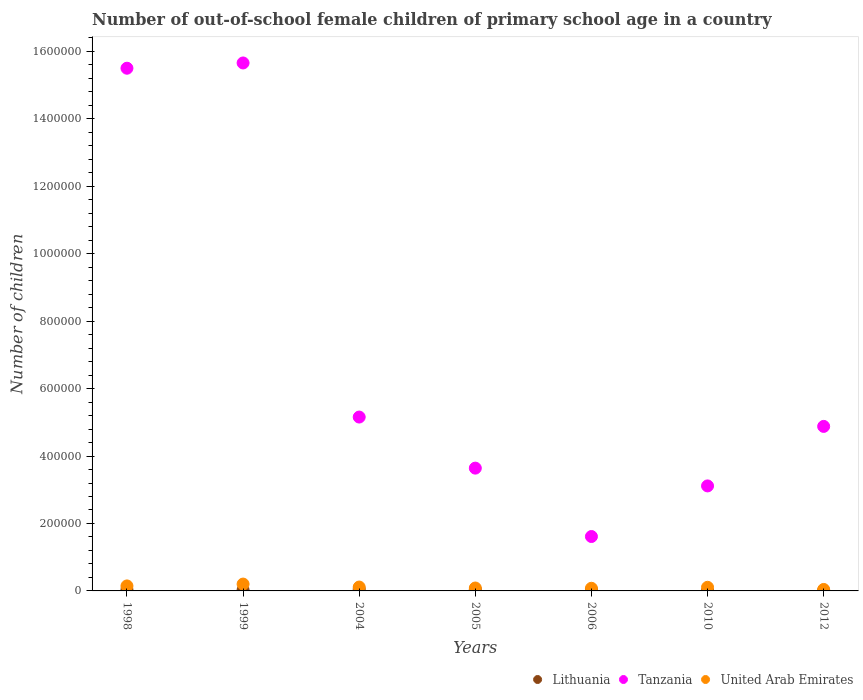How many different coloured dotlines are there?
Offer a terse response. 3. Is the number of dotlines equal to the number of legend labels?
Keep it short and to the point. Yes. What is the number of out-of-school female children in Tanzania in 2006?
Your answer should be very brief. 1.61e+05. Across all years, what is the maximum number of out-of-school female children in Lithuania?
Ensure brevity in your answer.  5354. Across all years, what is the minimum number of out-of-school female children in Lithuania?
Provide a succinct answer. 857. In which year was the number of out-of-school female children in Tanzania maximum?
Provide a succinct answer. 1999. What is the total number of out-of-school female children in Lithuania in the graph?
Your answer should be compact. 2.16e+04. What is the difference between the number of out-of-school female children in Tanzania in 2005 and that in 2006?
Your answer should be compact. 2.03e+05. What is the difference between the number of out-of-school female children in Tanzania in 1998 and the number of out-of-school female children in Lithuania in 2005?
Keep it short and to the point. 1.55e+06. What is the average number of out-of-school female children in United Arab Emirates per year?
Give a very brief answer. 1.12e+04. In the year 1999, what is the difference between the number of out-of-school female children in Tanzania and number of out-of-school female children in United Arab Emirates?
Your response must be concise. 1.55e+06. In how many years, is the number of out-of-school female children in Lithuania greater than 1200000?
Offer a terse response. 0. What is the ratio of the number of out-of-school female children in Tanzania in 1999 to that in 2006?
Your response must be concise. 9.7. Is the number of out-of-school female children in Lithuania in 2004 less than that in 2012?
Provide a succinct answer. No. Is the difference between the number of out-of-school female children in Tanzania in 1999 and 2010 greater than the difference between the number of out-of-school female children in United Arab Emirates in 1999 and 2010?
Your response must be concise. Yes. What is the difference between the highest and the second highest number of out-of-school female children in Tanzania?
Provide a short and direct response. 1.56e+04. What is the difference between the highest and the lowest number of out-of-school female children in United Arab Emirates?
Offer a terse response. 1.59e+04. In how many years, is the number of out-of-school female children in United Arab Emirates greater than the average number of out-of-school female children in United Arab Emirates taken over all years?
Your answer should be compact. 3. Is it the case that in every year, the sum of the number of out-of-school female children in United Arab Emirates and number of out-of-school female children in Lithuania  is greater than the number of out-of-school female children in Tanzania?
Keep it short and to the point. No. Does the number of out-of-school female children in Tanzania monotonically increase over the years?
Offer a very short reply. No. Is the number of out-of-school female children in Tanzania strictly greater than the number of out-of-school female children in United Arab Emirates over the years?
Make the answer very short. Yes. Is the number of out-of-school female children in United Arab Emirates strictly less than the number of out-of-school female children in Lithuania over the years?
Keep it short and to the point. No. How many years are there in the graph?
Provide a succinct answer. 7. What is the difference between two consecutive major ticks on the Y-axis?
Give a very brief answer. 2.00e+05. Does the graph contain grids?
Keep it short and to the point. No. Where does the legend appear in the graph?
Provide a succinct answer. Bottom right. How many legend labels are there?
Your response must be concise. 3. How are the legend labels stacked?
Provide a short and direct response. Horizontal. What is the title of the graph?
Your answer should be compact. Number of out-of-school female children of primary school age in a country. What is the label or title of the Y-axis?
Provide a short and direct response. Number of children. What is the Number of children of Lithuania in 1998?
Your answer should be compact. 3783. What is the Number of children in Tanzania in 1998?
Your answer should be compact. 1.55e+06. What is the Number of children in United Arab Emirates in 1998?
Your answer should be compact. 1.48e+04. What is the Number of children of Lithuania in 1999?
Provide a succinct answer. 2998. What is the Number of children of Tanzania in 1999?
Provide a short and direct response. 1.57e+06. What is the Number of children of United Arab Emirates in 1999?
Keep it short and to the point. 2.03e+04. What is the Number of children of Lithuania in 2004?
Keep it short and to the point. 5354. What is the Number of children in Tanzania in 2004?
Ensure brevity in your answer.  5.16e+05. What is the Number of children of United Arab Emirates in 2004?
Give a very brief answer. 1.15e+04. What is the Number of children of Lithuania in 2005?
Make the answer very short. 4559. What is the Number of children of Tanzania in 2005?
Your response must be concise. 3.64e+05. What is the Number of children in United Arab Emirates in 2005?
Offer a very short reply. 8644. What is the Number of children in Lithuania in 2006?
Make the answer very short. 2854. What is the Number of children of Tanzania in 2006?
Your answer should be compact. 1.61e+05. What is the Number of children in United Arab Emirates in 2006?
Ensure brevity in your answer.  7870. What is the Number of children in Lithuania in 2010?
Provide a succinct answer. 857. What is the Number of children of Tanzania in 2010?
Keep it short and to the point. 3.11e+05. What is the Number of children in United Arab Emirates in 2010?
Give a very brief answer. 1.08e+04. What is the Number of children in Lithuania in 2012?
Provide a succinct answer. 1167. What is the Number of children of Tanzania in 2012?
Ensure brevity in your answer.  4.88e+05. What is the Number of children of United Arab Emirates in 2012?
Your response must be concise. 4362. Across all years, what is the maximum Number of children in Lithuania?
Make the answer very short. 5354. Across all years, what is the maximum Number of children in Tanzania?
Your answer should be compact. 1.57e+06. Across all years, what is the maximum Number of children of United Arab Emirates?
Offer a very short reply. 2.03e+04. Across all years, what is the minimum Number of children in Lithuania?
Provide a short and direct response. 857. Across all years, what is the minimum Number of children in Tanzania?
Provide a succinct answer. 1.61e+05. Across all years, what is the minimum Number of children in United Arab Emirates?
Your answer should be very brief. 4362. What is the total Number of children of Lithuania in the graph?
Provide a short and direct response. 2.16e+04. What is the total Number of children of Tanzania in the graph?
Provide a succinct answer. 4.96e+06. What is the total Number of children in United Arab Emirates in the graph?
Give a very brief answer. 7.83e+04. What is the difference between the Number of children of Lithuania in 1998 and that in 1999?
Ensure brevity in your answer.  785. What is the difference between the Number of children of Tanzania in 1998 and that in 1999?
Your answer should be very brief. -1.56e+04. What is the difference between the Number of children of United Arab Emirates in 1998 and that in 1999?
Offer a terse response. -5477. What is the difference between the Number of children in Lithuania in 1998 and that in 2004?
Make the answer very short. -1571. What is the difference between the Number of children in Tanzania in 1998 and that in 2004?
Your answer should be very brief. 1.03e+06. What is the difference between the Number of children in United Arab Emirates in 1998 and that in 2004?
Give a very brief answer. 3322. What is the difference between the Number of children in Lithuania in 1998 and that in 2005?
Make the answer very short. -776. What is the difference between the Number of children in Tanzania in 1998 and that in 2005?
Keep it short and to the point. 1.19e+06. What is the difference between the Number of children in United Arab Emirates in 1998 and that in 2005?
Provide a succinct answer. 6178. What is the difference between the Number of children in Lithuania in 1998 and that in 2006?
Provide a short and direct response. 929. What is the difference between the Number of children of Tanzania in 1998 and that in 2006?
Ensure brevity in your answer.  1.39e+06. What is the difference between the Number of children of United Arab Emirates in 1998 and that in 2006?
Provide a succinct answer. 6952. What is the difference between the Number of children in Lithuania in 1998 and that in 2010?
Make the answer very short. 2926. What is the difference between the Number of children in Tanzania in 1998 and that in 2010?
Give a very brief answer. 1.24e+06. What is the difference between the Number of children in United Arab Emirates in 1998 and that in 2010?
Your answer should be very brief. 4048. What is the difference between the Number of children in Lithuania in 1998 and that in 2012?
Ensure brevity in your answer.  2616. What is the difference between the Number of children in Tanzania in 1998 and that in 2012?
Your response must be concise. 1.06e+06. What is the difference between the Number of children in United Arab Emirates in 1998 and that in 2012?
Your answer should be compact. 1.05e+04. What is the difference between the Number of children in Lithuania in 1999 and that in 2004?
Provide a succinct answer. -2356. What is the difference between the Number of children in Tanzania in 1999 and that in 2004?
Make the answer very short. 1.05e+06. What is the difference between the Number of children in United Arab Emirates in 1999 and that in 2004?
Offer a terse response. 8799. What is the difference between the Number of children of Lithuania in 1999 and that in 2005?
Offer a very short reply. -1561. What is the difference between the Number of children of Tanzania in 1999 and that in 2005?
Provide a succinct answer. 1.20e+06. What is the difference between the Number of children in United Arab Emirates in 1999 and that in 2005?
Make the answer very short. 1.17e+04. What is the difference between the Number of children in Lithuania in 1999 and that in 2006?
Your answer should be compact. 144. What is the difference between the Number of children of Tanzania in 1999 and that in 2006?
Offer a terse response. 1.40e+06. What is the difference between the Number of children in United Arab Emirates in 1999 and that in 2006?
Make the answer very short. 1.24e+04. What is the difference between the Number of children in Lithuania in 1999 and that in 2010?
Offer a very short reply. 2141. What is the difference between the Number of children in Tanzania in 1999 and that in 2010?
Provide a succinct answer. 1.25e+06. What is the difference between the Number of children of United Arab Emirates in 1999 and that in 2010?
Your answer should be very brief. 9525. What is the difference between the Number of children in Lithuania in 1999 and that in 2012?
Ensure brevity in your answer.  1831. What is the difference between the Number of children in Tanzania in 1999 and that in 2012?
Your answer should be compact. 1.08e+06. What is the difference between the Number of children of United Arab Emirates in 1999 and that in 2012?
Give a very brief answer. 1.59e+04. What is the difference between the Number of children in Lithuania in 2004 and that in 2005?
Your answer should be very brief. 795. What is the difference between the Number of children in Tanzania in 2004 and that in 2005?
Your response must be concise. 1.51e+05. What is the difference between the Number of children in United Arab Emirates in 2004 and that in 2005?
Offer a very short reply. 2856. What is the difference between the Number of children in Lithuania in 2004 and that in 2006?
Provide a short and direct response. 2500. What is the difference between the Number of children of Tanzania in 2004 and that in 2006?
Give a very brief answer. 3.54e+05. What is the difference between the Number of children in United Arab Emirates in 2004 and that in 2006?
Give a very brief answer. 3630. What is the difference between the Number of children of Lithuania in 2004 and that in 2010?
Ensure brevity in your answer.  4497. What is the difference between the Number of children in Tanzania in 2004 and that in 2010?
Offer a very short reply. 2.04e+05. What is the difference between the Number of children of United Arab Emirates in 2004 and that in 2010?
Your response must be concise. 726. What is the difference between the Number of children of Lithuania in 2004 and that in 2012?
Offer a terse response. 4187. What is the difference between the Number of children of Tanzania in 2004 and that in 2012?
Make the answer very short. 2.77e+04. What is the difference between the Number of children in United Arab Emirates in 2004 and that in 2012?
Your answer should be compact. 7138. What is the difference between the Number of children of Lithuania in 2005 and that in 2006?
Your answer should be compact. 1705. What is the difference between the Number of children in Tanzania in 2005 and that in 2006?
Your answer should be very brief. 2.03e+05. What is the difference between the Number of children in United Arab Emirates in 2005 and that in 2006?
Your response must be concise. 774. What is the difference between the Number of children of Lithuania in 2005 and that in 2010?
Offer a very short reply. 3702. What is the difference between the Number of children of Tanzania in 2005 and that in 2010?
Provide a succinct answer. 5.27e+04. What is the difference between the Number of children in United Arab Emirates in 2005 and that in 2010?
Your answer should be very brief. -2130. What is the difference between the Number of children of Lithuania in 2005 and that in 2012?
Your response must be concise. 3392. What is the difference between the Number of children of Tanzania in 2005 and that in 2012?
Your answer should be compact. -1.24e+05. What is the difference between the Number of children in United Arab Emirates in 2005 and that in 2012?
Your answer should be compact. 4282. What is the difference between the Number of children of Lithuania in 2006 and that in 2010?
Your answer should be compact. 1997. What is the difference between the Number of children of Tanzania in 2006 and that in 2010?
Your response must be concise. -1.50e+05. What is the difference between the Number of children of United Arab Emirates in 2006 and that in 2010?
Provide a succinct answer. -2904. What is the difference between the Number of children of Lithuania in 2006 and that in 2012?
Offer a very short reply. 1687. What is the difference between the Number of children of Tanzania in 2006 and that in 2012?
Keep it short and to the point. -3.27e+05. What is the difference between the Number of children of United Arab Emirates in 2006 and that in 2012?
Your answer should be compact. 3508. What is the difference between the Number of children in Lithuania in 2010 and that in 2012?
Give a very brief answer. -310. What is the difference between the Number of children in Tanzania in 2010 and that in 2012?
Keep it short and to the point. -1.76e+05. What is the difference between the Number of children of United Arab Emirates in 2010 and that in 2012?
Keep it short and to the point. 6412. What is the difference between the Number of children of Lithuania in 1998 and the Number of children of Tanzania in 1999?
Offer a very short reply. -1.56e+06. What is the difference between the Number of children in Lithuania in 1998 and the Number of children in United Arab Emirates in 1999?
Provide a succinct answer. -1.65e+04. What is the difference between the Number of children in Tanzania in 1998 and the Number of children in United Arab Emirates in 1999?
Keep it short and to the point. 1.53e+06. What is the difference between the Number of children in Lithuania in 1998 and the Number of children in Tanzania in 2004?
Offer a terse response. -5.12e+05. What is the difference between the Number of children in Lithuania in 1998 and the Number of children in United Arab Emirates in 2004?
Offer a very short reply. -7717. What is the difference between the Number of children in Tanzania in 1998 and the Number of children in United Arab Emirates in 2004?
Offer a very short reply. 1.54e+06. What is the difference between the Number of children of Lithuania in 1998 and the Number of children of Tanzania in 2005?
Provide a short and direct response. -3.60e+05. What is the difference between the Number of children in Lithuania in 1998 and the Number of children in United Arab Emirates in 2005?
Your response must be concise. -4861. What is the difference between the Number of children in Tanzania in 1998 and the Number of children in United Arab Emirates in 2005?
Offer a terse response. 1.54e+06. What is the difference between the Number of children in Lithuania in 1998 and the Number of children in Tanzania in 2006?
Give a very brief answer. -1.58e+05. What is the difference between the Number of children of Lithuania in 1998 and the Number of children of United Arab Emirates in 2006?
Offer a terse response. -4087. What is the difference between the Number of children in Tanzania in 1998 and the Number of children in United Arab Emirates in 2006?
Your answer should be very brief. 1.54e+06. What is the difference between the Number of children in Lithuania in 1998 and the Number of children in Tanzania in 2010?
Offer a terse response. -3.08e+05. What is the difference between the Number of children of Lithuania in 1998 and the Number of children of United Arab Emirates in 2010?
Provide a succinct answer. -6991. What is the difference between the Number of children in Tanzania in 1998 and the Number of children in United Arab Emirates in 2010?
Ensure brevity in your answer.  1.54e+06. What is the difference between the Number of children in Lithuania in 1998 and the Number of children in Tanzania in 2012?
Keep it short and to the point. -4.84e+05. What is the difference between the Number of children of Lithuania in 1998 and the Number of children of United Arab Emirates in 2012?
Your answer should be very brief. -579. What is the difference between the Number of children of Tanzania in 1998 and the Number of children of United Arab Emirates in 2012?
Make the answer very short. 1.55e+06. What is the difference between the Number of children in Lithuania in 1999 and the Number of children in Tanzania in 2004?
Your answer should be very brief. -5.13e+05. What is the difference between the Number of children in Lithuania in 1999 and the Number of children in United Arab Emirates in 2004?
Ensure brevity in your answer.  -8502. What is the difference between the Number of children in Tanzania in 1999 and the Number of children in United Arab Emirates in 2004?
Provide a short and direct response. 1.55e+06. What is the difference between the Number of children in Lithuania in 1999 and the Number of children in Tanzania in 2005?
Your answer should be very brief. -3.61e+05. What is the difference between the Number of children in Lithuania in 1999 and the Number of children in United Arab Emirates in 2005?
Provide a succinct answer. -5646. What is the difference between the Number of children of Tanzania in 1999 and the Number of children of United Arab Emirates in 2005?
Offer a terse response. 1.56e+06. What is the difference between the Number of children in Lithuania in 1999 and the Number of children in Tanzania in 2006?
Provide a succinct answer. -1.58e+05. What is the difference between the Number of children in Lithuania in 1999 and the Number of children in United Arab Emirates in 2006?
Give a very brief answer. -4872. What is the difference between the Number of children in Tanzania in 1999 and the Number of children in United Arab Emirates in 2006?
Give a very brief answer. 1.56e+06. What is the difference between the Number of children of Lithuania in 1999 and the Number of children of Tanzania in 2010?
Your response must be concise. -3.08e+05. What is the difference between the Number of children of Lithuania in 1999 and the Number of children of United Arab Emirates in 2010?
Ensure brevity in your answer.  -7776. What is the difference between the Number of children of Tanzania in 1999 and the Number of children of United Arab Emirates in 2010?
Offer a very short reply. 1.55e+06. What is the difference between the Number of children of Lithuania in 1999 and the Number of children of Tanzania in 2012?
Offer a terse response. -4.85e+05. What is the difference between the Number of children in Lithuania in 1999 and the Number of children in United Arab Emirates in 2012?
Ensure brevity in your answer.  -1364. What is the difference between the Number of children of Tanzania in 1999 and the Number of children of United Arab Emirates in 2012?
Make the answer very short. 1.56e+06. What is the difference between the Number of children of Lithuania in 2004 and the Number of children of Tanzania in 2005?
Provide a succinct answer. -3.59e+05. What is the difference between the Number of children of Lithuania in 2004 and the Number of children of United Arab Emirates in 2005?
Make the answer very short. -3290. What is the difference between the Number of children of Tanzania in 2004 and the Number of children of United Arab Emirates in 2005?
Give a very brief answer. 5.07e+05. What is the difference between the Number of children of Lithuania in 2004 and the Number of children of Tanzania in 2006?
Ensure brevity in your answer.  -1.56e+05. What is the difference between the Number of children of Lithuania in 2004 and the Number of children of United Arab Emirates in 2006?
Make the answer very short. -2516. What is the difference between the Number of children of Tanzania in 2004 and the Number of children of United Arab Emirates in 2006?
Provide a short and direct response. 5.08e+05. What is the difference between the Number of children of Lithuania in 2004 and the Number of children of Tanzania in 2010?
Keep it short and to the point. -3.06e+05. What is the difference between the Number of children of Lithuania in 2004 and the Number of children of United Arab Emirates in 2010?
Provide a succinct answer. -5420. What is the difference between the Number of children in Tanzania in 2004 and the Number of children in United Arab Emirates in 2010?
Offer a terse response. 5.05e+05. What is the difference between the Number of children in Lithuania in 2004 and the Number of children in Tanzania in 2012?
Provide a succinct answer. -4.83e+05. What is the difference between the Number of children in Lithuania in 2004 and the Number of children in United Arab Emirates in 2012?
Your answer should be compact. 992. What is the difference between the Number of children in Tanzania in 2004 and the Number of children in United Arab Emirates in 2012?
Offer a terse response. 5.11e+05. What is the difference between the Number of children of Lithuania in 2005 and the Number of children of Tanzania in 2006?
Your answer should be very brief. -1.57e+05. What is the difference between the Number of children of Lithuania in 2005 and the Number of children of United Arab Emirates in 2006?
Your answer should be very brief. -3311. What is the difference between the Number of children in Tanzania in 2005 and the Number of children in United Arab Emirates in 2006?
Make the answer very short. 3.56e+05. What is the difference between the Number of children of Lithuania in 2005 and the Number of children of Tanzania in 2010?
Your response must be concise. -3.07e+05. What is the difference between the Number of children of Lithuania in 2005 and the Number of children of United Arab Emirates in 2010?
Provide a succinct answer. -6215. What is the difference between the Number of children of Tanzania in 2005 and the Number of children of United Arab Emirates in 2010?
Provide a succinct answer. 3.53e+05. What is the difference between the Number of children of Lithuania in 2005 and the Number of children of Tanzania in 2012?
Your response must be concise. -4.83e+05. What is the difference between the Number of children in Lithuania in 2005 and the Number of children in United Arab Emirates in 2012?
Keep it short and to the point. 197. What is the difference between the Number of children in Tanzania in 2005 and the Number of children in United Arab Emirates in 2012?
Provide a short and direct response. 3.60e+05. What is the difference between the Number of children in Lithuania in 2006 and the Number of children in Tanzania in 2010?
Your answer should be very brief. -3.09e+05. What is the difference between the Number of children of Lithuania in 2006 and the Number of children of United Arab Emirates in 2010?
Keep it short and to the point. -7920. What is the difference between the Number of children in Tanzania in 2006 and the Number of children in United Arab Emirates in 2010?
Make the answer very short. 1.51e+05. What is the difference between the Number of children in Lithuania in 2006 and the Number of children in Tanzania in 2012?
Offer a terse response. -4.85e+05. What is the difference between the Number of children of Lithuania in 2006 and the Number of children of United Arab Emirates in 2012?
Keep it short and to the point. -1508. What is the difference between the Number of children of Tanzania in 2006 and the Number of children of United Arab Emirates in 2012?
Your response must be concise. 1.57e+05. What is the difference between the Number of children in Lithuania in 2010 and the Number of children in Tanzania in 2012?
Your response must be concise. -4.87e+05. What is the difference between the Number of children in Lithuania in 2010 and the Number of children in United Arab Emirates in 2012?
Offer a terse response. -3505. What is the difference between the Number of children in Tanzania in 2010 and the Number of children in United Arab Emirates in 2012?
Keep it short and to the point. 3.07e+05. What is the average Number of children of Lithuania per year?
Provide a short and direct response. 3081.71. What is the average Number of children of Tanzania per year?
Your response must be concise. 7.08e+05. What is the average Number of children in United Arab Emirates per year?
Keep it short and to the point. 1.12e+04. In the year 1998, what is the difference between the Number of children of Lithuania and Number of children of Tanzania?
Offer a very short reply. -1.55e+06. In the year 1998, what is the difference between the Number of children in Lithuania and Number of children in United Arab Emirates?
Keep it short and to the point. -1.10e+04. In the year 1998, what is the difference between the Number of children of Tanzania and Number of children of United Arab Emirates?
Your answer should be very brief. 1.54e+06. In the year 1999, what is the difference between the Number of children of Lithuania and Number of children of Tanzania?
Make the answer very short. -1.56e+06. In the year 1999, what is the difference between the Number of children in Lithuania and Number of children in United Arab Emirates?
Give a very brief answer. -1.73e+04. In the year 1999, what is the difference between the Number of children of Tanzania and Number of children of United Arab Emirates?
Provide a succinct answer. 1.55e+06. In the year 2004, what is the difference between the Number of children of Lithuania and Number of children of Tanzania?
Offer a terse response. -5.10e+05. In the year 2004, what is the difference between the Number of children of Lithuania and Number of children of United Arab Emirates?
Provide a short and direct response. -6146. In the year 2004, what is the difference between the Number of children in Tanzania and Number of children in United Arab Emirates?
Make the answer very short. 5.04e+05. In the year 2005, what is the difference between the Number of children in Lithuania and Number of children in Tanzania?
Keep it short and to the point. -3.60e+05. In the year 2005, what is the difference between the Number of children of Lithuania and Number of children of United Arab Emirates?
Provide a short and direct response. -4085. In the year 2005, what is the difference between the Number of children of Tanzania and Number of children of United Arab Emirates?
Your answer should be very brief. 3.55e+05. In the year 2006, what is the difference between the Number of children of Lithuania and Number of children of Tanzania?
Offer a terse response. -1.58e+05. In the year 2006, what is the difference between the Number of children in Lithuania and Number of children in United Arab Emirates?
Ensure brevity in your answer.  -5016. In the year 2006, what is the difference between the Number of children of Tanzania and Number of children of United Arab Emirates?
Your answer should be very brief. 1.53e+05. In the year 2010, what is the difference between the Number of children of Lithuania and Number of children of Tanzania?
Your answer should be compact. -3.11e+05. In the year 2010, what is the difference between the Number of children in Lithuania and Number of children in United Arab Emirates?
Provide a succinct answer. -9917. In the year 2010, what is the difference between the Number of children in Tanzania and Number of children in United Arab Emirates?
Offer a terse response. 3.01e+05. In the year 2012, what is the difference between the Number of children in Lithuania and Number of children in Tanzania?
Your answer should be very brief. -4.87e+05. In the year 2012, what is the difference between the Number of children in Lithuania and Number of children in United Arab Emirates?
Make the answer very short. -3195. In the year 2012, what is the difference between the Number of children in Tanzania and Number of children in United Arab Emirates?
Offer a terse response. 4.84e+05. What is the ratio of the Number of children in Lithuania in 1998 to that in 1999?
Keep it short and to the point. 1.26. What is the ratio of the Number of children in Tanzania in 1998 to that in 1999?
Give a very brief answer. 0.99. What is the ratio of the Number of children of United Arab Emirates in 1998 to that in 1999?
Provide a short and direct response. 0.73. What is the ratio of the Number of children of Lithuania in 1998 to that in 2004?
Keep it short and to the point. 0.71. What is the ratio of the Number of children in Tanzania in 1998 to that in 2004?
Make the answer very short. 3.01. What is the ratio of the Number of children in United Arab Emirates in 1998 to that in 2004?
Offer a very short reply. 1.29. What is the ratio of the Number of children in Lithuania in 1998 to that in 2005?
Make the answer very short. 0.83. What is the ratio of the Number of children of Tanzania in 1998 to that in 2005?
Offer a terse response. 4.26. What is the ratio of the Number of children of United Arab Emirates in 1998 to that in 2005?
Offer a terse response. 1.71. What is the ratio of the Number of children in Lithuania in 1998 to that in 2006?
Keep it short and to the point. 1.33. What is the ratio of the Number of children in Tanzania in 1998 to that in 2006?
Offer a very short reply. 9.61. What is the ratio of the Number of children in United Arab Emirates in 1998 to that in 2006?
Your response must be concise. 1.88. What is the ratio of the Number of children of Lithuania in 1998 to that in 2010?
Provide a succinct answer. 4.41. What is the ratio of the Number of children in Tanzania in 1998 to that in 2010?
Your response must be concise. 4.98. What is the ratio of the Number of children of United Arab Emirates in 1998 to that in 2010?
Your answer should be compact. 1.38. What is the ratio of the Number of children of Lithuania in 1998 to that in 2012?
Your response must be concise. 3.24. What is the ratio of the Number of children of Tanzania in 1998 to that in 2012?
Give a very brief answer. 3.18. What is the ratio of the Number of children in United Arab Emirates in 1998 to that in 2012?
Your response must be concise. 3.4. What is the ratio of the Number of children in Lithuania in 1999 to that in 2004?
Give a very brief answer. 0.56. What is the ratio of the Number of children in Tanzania in 1999 to that in 2004?
Offer a very short reply. 3.04. What is the ratio of the Number of children in United Arab Emirates in 1999 to that in 2004?
Keep it short and to the point. 1.77. What is the ratio of the Number of children in Lithuania in 1999 to that in 2005?
Your answer should be very brief. 0.66. What is the ratio of the Number of children in Tanzania in 1999 to that in 2005?
Your response must be concise. 4.3. What is the ratio of the Number of children of United Arab Emirates in 1999 to that in 2005?
Your answer should be very brief. 2.35. What is the ratio of the Number of children of Lithuania in 1999 to that in 2006?
Provide a short and direct response. 1.05. What is the ratio of the Number of children of Tanzania in 1999 to that in 2006?
Your response must be concise. 9.7. What is the ratio of the Number of children in United Arab Emirates in 1999 to that in 2006?
Your response must be concise. 2.58. What is the ratio of the Number of children of Lithuania in 1999 to that in 2010?
Offer a very short reply. 3.5. What is the ratio of the Number of children of Tanzania in 1999 to that in 2010?
Provide a short and direct response. 5.03. What is the ratio of the Number of children of United Arab Emirates in 1999 to that in 2010?
Offer a very short reply. 1.88. What is the ratio of the Number of children of Lithuania in 1999 to that in 2012?
Your answer should be compact. 2.57. What is the ratio of the Number of children in Tanzania in 1999 to that in 2012?
Offer a very short reply. 3.21. What is the ratio of the Number of children of United Arab Emirates in 1999 to that in 2012?
Your response must be concise. 4.65. What is the ratio of the Number of children of Lithuania in 2004 to that in 2005?
Your response must be concise. 1.17. What is the ratio of the Number of children of Tanzania in 2004 to that in 2005?
Your response must be concise. 1.42. What is the ratio of the Number of children in United Arab Emirates in 2004 to that in 2005?
Keep it short and to the point. 1.33. What is the ratio of the Number of children of Lithuania in 2004 to that in 2006?
Provide a short and direct response. 1.88. What is the ratio of the Number of children in Tanzania in 2004 to that in 2006?
Your answer should be very brief. 3.2. What is the ratio of the Number of children in United Arab Emirates in 2004 to that in 2006?
Provide a short and direct response. 1.46. What is the ratio of the Number of children of Lithuania in 2004 to that in 2010?
Your response must be concise. 6.25. What is the ratio of the Number of children in Tanzania in 2004 to that in 2010?
Your response must be concise. 1.66. What is the ratio of the Number of children in United Arab Emirates in 2004 to that in 2010?
Provide a short and direct response. 1.07. What is the ratio of the Number of children in Lithuania in 2004 to that in 2012?
Keep it short and to the point. 4.59. What is the ratio of the Number of children in Tanzania in 2004 to that in 2012?
Ensure brevity in your answer.  1.06. What is the ratio of the Number of children of United Arab Emirates in 2004 to that in 2012?
Ensure brevity in your answer.  2.64. What is the ratio of the Number of children in Lithuania in 2005 to that in 2006?
Make the answer very short. 1.6. What is the ratio of the Number of children of Tanzania in 2005 to that in 2006?
Keep it short and to the point. 2.26. What is the ratio of the Number of children in United Arab Emirates in 2005 to that in 2006?
Ensure brevity in your answer.  1.1. What is the ratio of the Number of children of Lithuania in 2005 to that in 2010?
Your answer should be compact. 5.32. What is the ratio of the Number of children in Tanzania in 2005 to that in 2010?
Provide a succinct answer. 1.17. What is the ratio of the Number of children of United Arab Emirates in 2005 to that in 2010?
Keep it short and to the point. 0.8. What is the ratio of the Number of children of Lithuania in 2005 to that in 2012?
Provide a succinct answer. 3.91. What is the ratio of the Number of children in Tanzania in 2005 to that in 2012?
Your answer should be compact. 0.75. What is the ratio of the Number of children in United Arab Emirates in 2005 to that in 2012?
Make the answer very short. 1.98. What is the ratio of the Number of children in Lithuania in 2006 to that in 2010?
Your answer should be compact. 3.33. What is the ratio of the Number of children of Tanzania in 2006 to that in 2010?
Make the answer very short. 0.52. What is the ratio of the Number of children of United Arab Emirates in 2006 to that in 2010?
Provide a short and direct response. 0.73. What is the ratio of the Number of children in Lithuania in 2006 to that in 2012?
Your response must be concise. 2.45. What is the ratio of the Number of children of Tanzania in 2006 to that in 2012?
Ensure brevity in your answer.  0.33. What is the ratio of the Number of children of United Arab Emirates in 2006 to that in 2012?
Offer a very short reply. 1.8. What is the ratio of the Number of children of Lithuania in 2010 to that in 2012?
Make the answer very short. 0.73. What is the ratio of the Number of children in Tanzania in 2010 to that in 2012?
Make the answer very short. 0.64. What is the ratio of the Number of children in United Arab Emirates in 2010 to that in 2012?
Give a very brief answer. 2.47. What is the difference between the highest and the second highest Number of children of Lithuania?
Your answer should be compact. 795. What is the difference between the highest and the second highest Number of children of Tanzania?
Make the answer very short. 1.56e+04. What is the difference between the highest and the second highest Number of children in United Arab Emirates?
Make the answer very short. 5477. What is the difference between the highest and the lowest Number of children in Lithuania?
Make the answer very short. 4497. What is the difference between the highest and the lowest Number of children of Tanzania?
Offer a terse response. 1.40e+06. What is the difference between the highest and the lowest Number of children in United Arab Emirates?
Provide a short and direct response. 1.59e+04. 